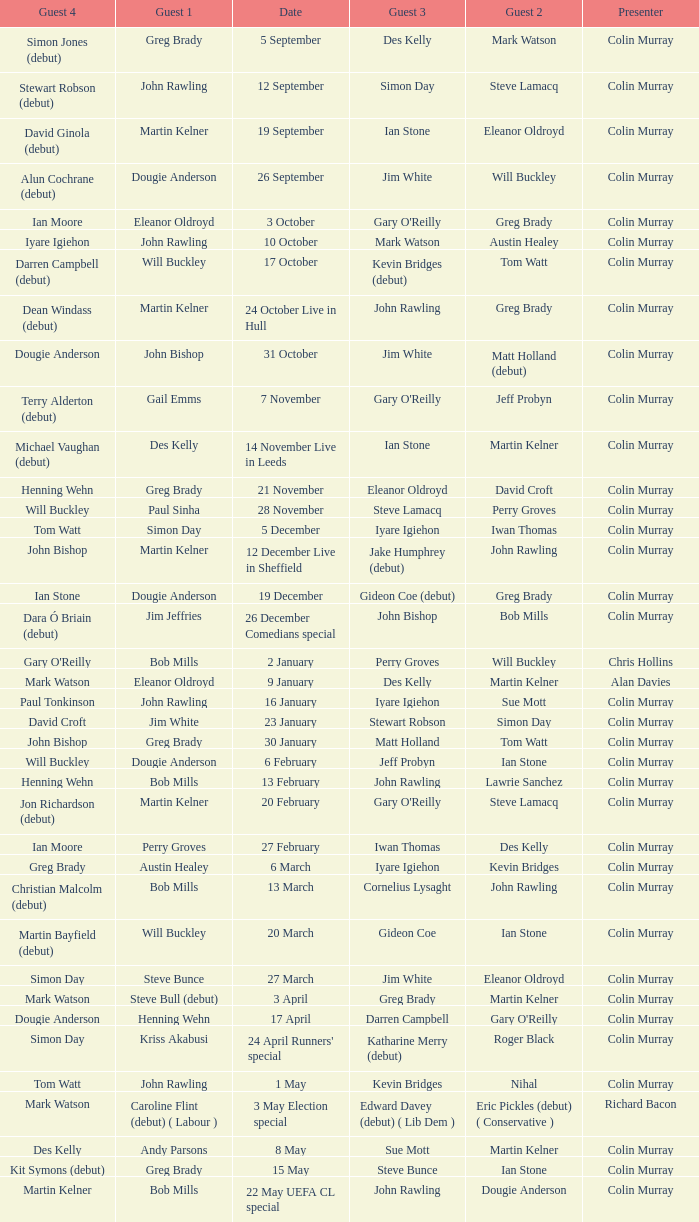How many people are guest 1 on episodes where guest 4 is Des Kelly? 1.0. 